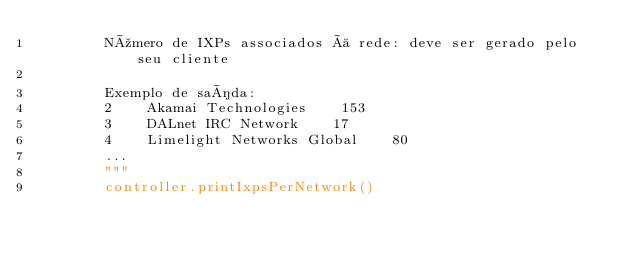Convert code to text. <code><loc_0><loc_0><loc_500><loc_500><_Python_>        Número de IXPs associados à rede: deve ser gerado pelo seu cliente

        Exemplo de saída:
        2    Akamai Technologies    153
        3    DALnet IRC Network    17
        4    Limelight Networks Global    80
        ...
        """
        controller.printIxpsPerNetwork()
</code> 